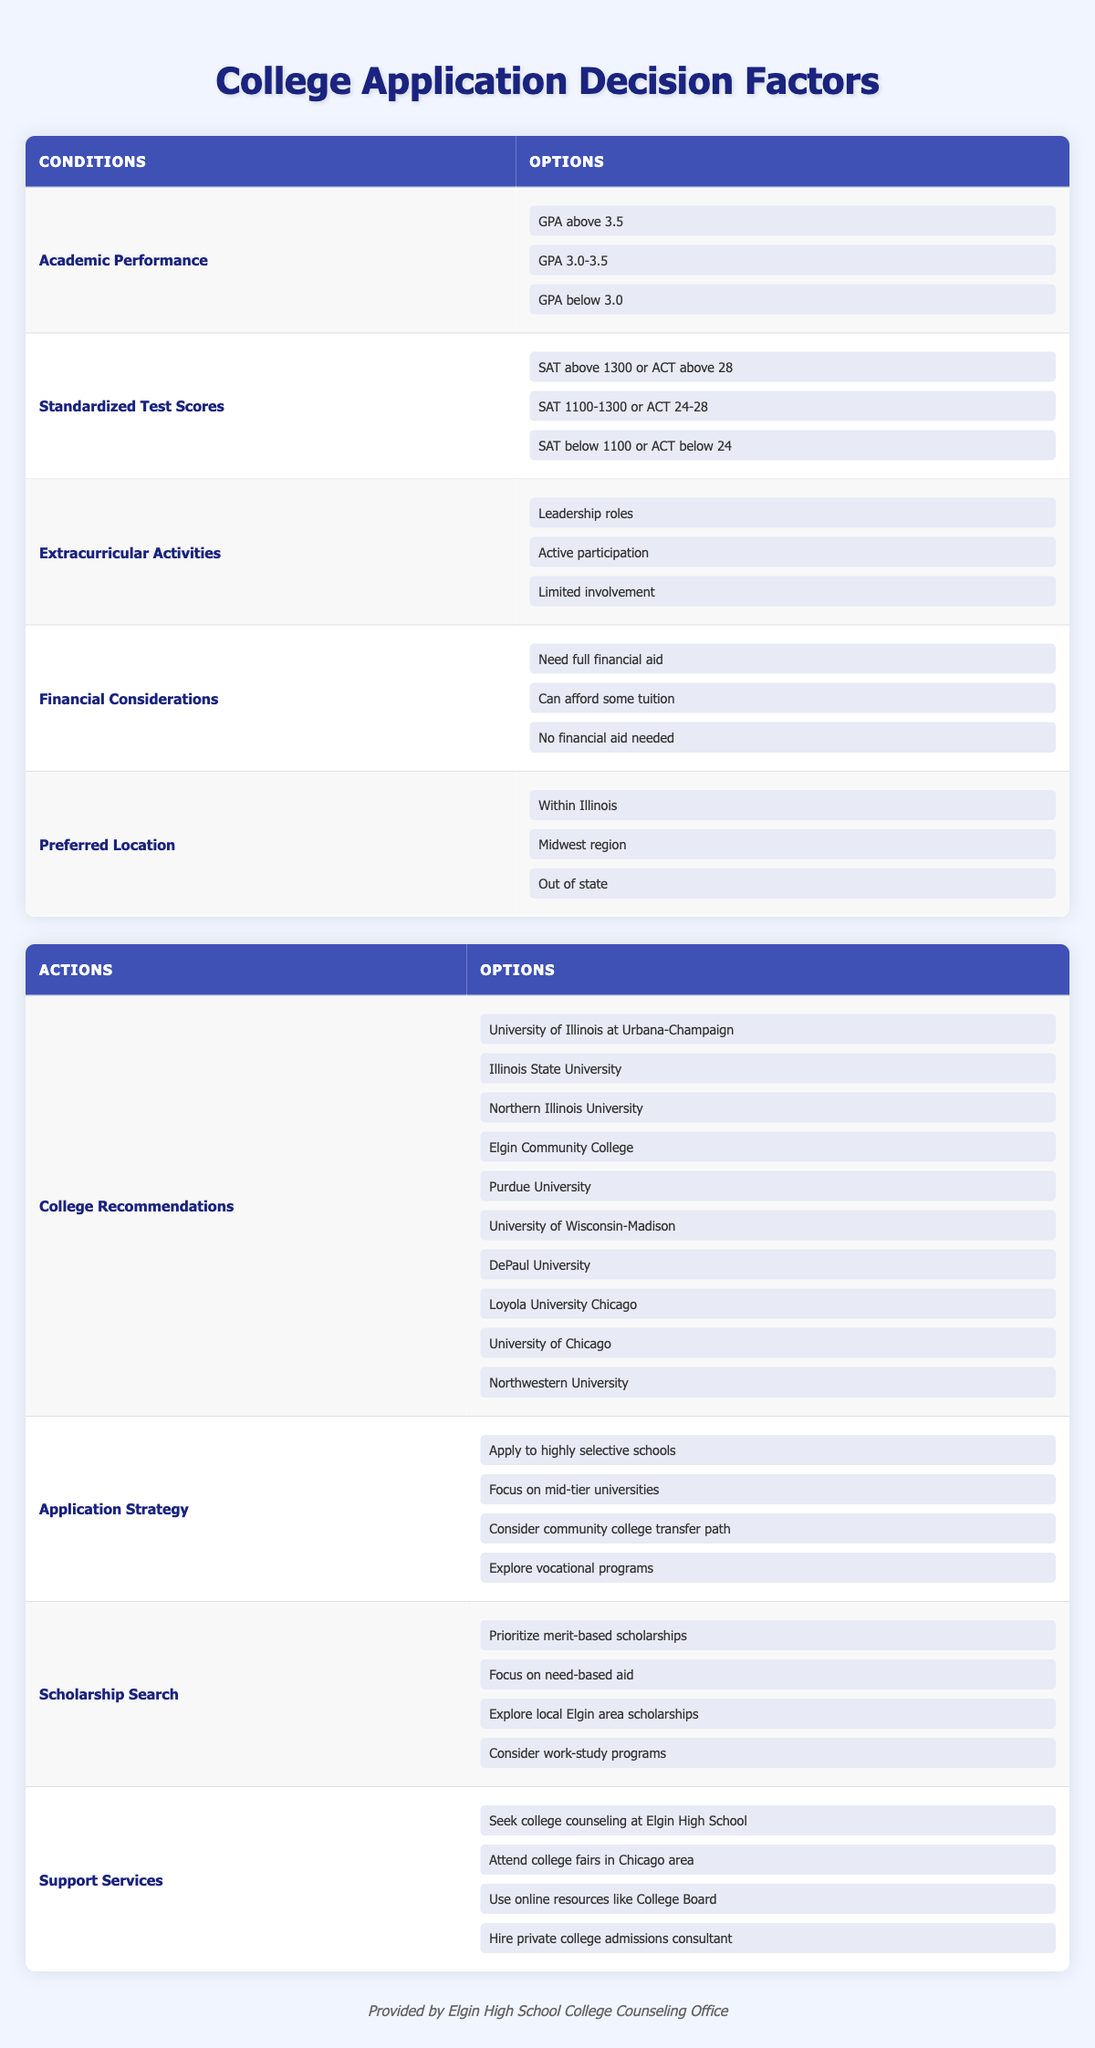What are the options for Academic Performance? According to the table, the options listed under Academic Performance are: GPA above 3.5, GPA 3.0-3.5, and GPA below 3.0.
Answer: GPA above 3.5, GPA 3.0-3.5, GPA below 3.0 What standardized test score range indicates a strong performance? The strong performance range for standardized test scores includes either SAT above 1300 or ACT above 28.
Answer: SAT above 1300 or ACT above 28 Are there options for financial considerations that involve needing full financial aid? Yes, one of the options listed under Financial Considerations is "Need full financial aid."
Answer: Yes Which colleges are recommended for someone with leadership roles in extracurricular activities? The recommendations do not change based on extracurricular involvement, but colleges like the University of Illinois at Urbana-Champaign and DePaul University might be appealing for those with strong extracurricular records.
Answer: University of Illinois at Urbana-Champaign, DePaul University What is the average number of scholarship search options available? There are four options listed for the scholarship search: prioritize merit-based scholarships, focus on need-based aid, explore local Elgin area scholarships, and consider work-study programs. To find the average, we count them, which is 4.
Answer: 4 Is there an option to seek support services specifically related to college counseling at Elgin High School? Yes, one of the options provided is to seek college counseling at Elgin High School.
Answer: Yes If a student can afford some tuition, what application strategy might be suggested? Based on the available actions, focusing on mid-tier universities could be a relevant application strategy for a student who can afford some tuition.
Answer: Focus on mid-tier universities If a student has a GPA above 3.5 and scores above the SAT threshold of 1300, what colleges are they likely to apply to? Given the high academic performance described, this student would likely apply to highly selective schools. Based on the recommended colleges, options may include University of Chicago, Northwestern University, and University of Illinois at Urbana-Champaign.
Answer: University of Chicago, Northwestern University, University of Illinois at Urbana-Champaign How many options are available for Preferred Location? Three options are listed under Preferred Location: Within Illinois, Midwest region, and Out of state. Therefore, the total count is three.
Answer: 3 